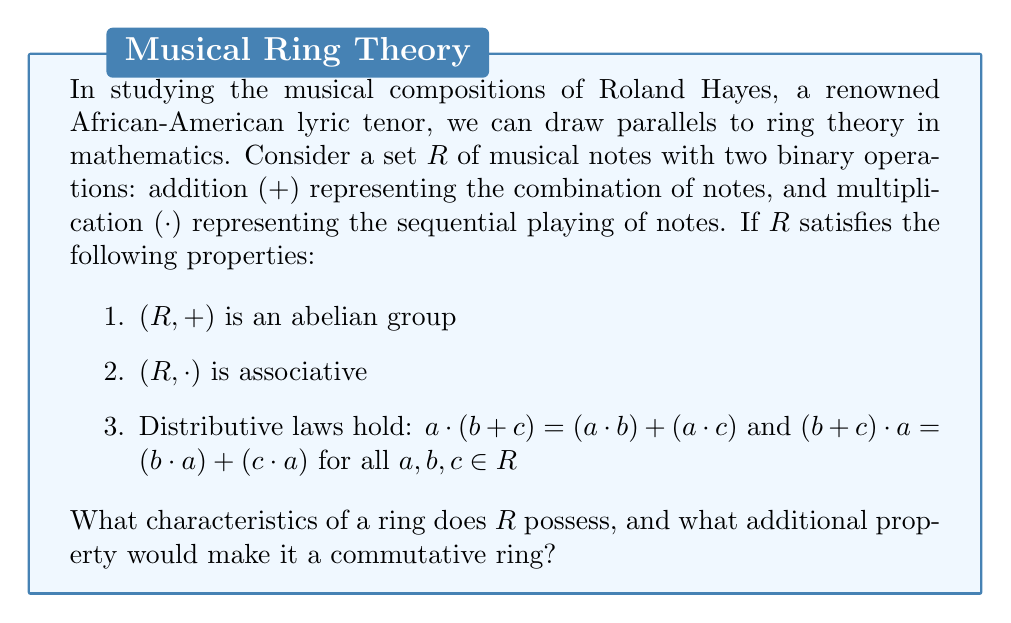Could you help me with this problem? Let's analyze the given properties step-by-step:

1. $(R, +)$ is an abelian group:
   This means that addition of musical notes is:
   - Associative: $(a + b) + c = a + (b + c)$
   - Commutative: $a + b = b + a$
   - Has an identity element (likely the silence or rest note): $\exists 0 \in R$ such that $a + 0 = a$ for all $a \in R$
   - Has inverses: For each $a \in R$, $\exists (-a) \in R$ such that $a + (-a) = 0$

2. $(R, \cdot)$ is associative:
   This means that sequential playing of notes follows the associative property:
   $(a \cdot b) \cdot c = a \cdot (b \cdot c)$

3. Distributive laws hold:
   This connects the two operations, showing how playing a note and then combining it with others is equivalent to combining first and then playing.

These three properties are precisely the defining characteristics of a ring. Therefore, $R$ is a ring.

To make $R$ a commutative ring, we need one additional property:

4. Commutativity of multiplication: $a \cdot b = b \cdot a$ for all $a, b \in R$

This would mean that the order of playing notes sequentially doesn't matter, which is generally not true in music but could be considered in certain abstract musical theories.
Answer: $R$ is a ring. Commutativity of multiplication ($a \cdot b = b \cdot a$) would make it a commutative ring. 